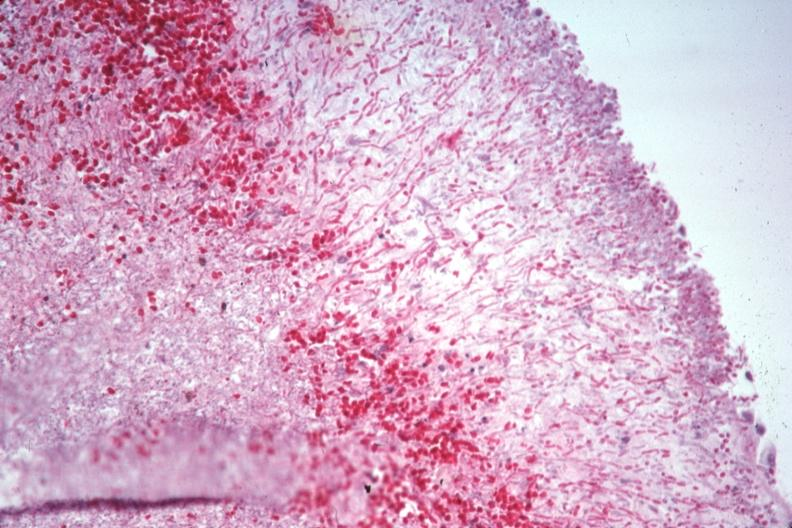what is present?
Answer the question using a single word or phrase. Candida 